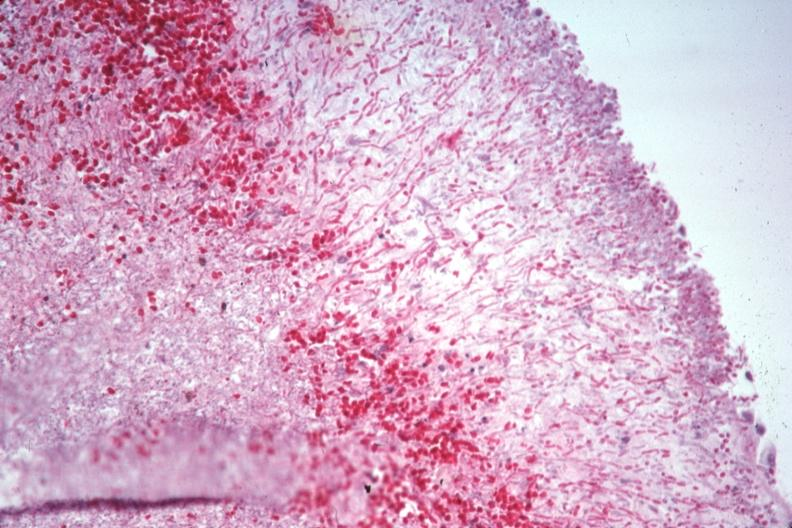what is present?
Answer the question using a single word or phrase. Candida 